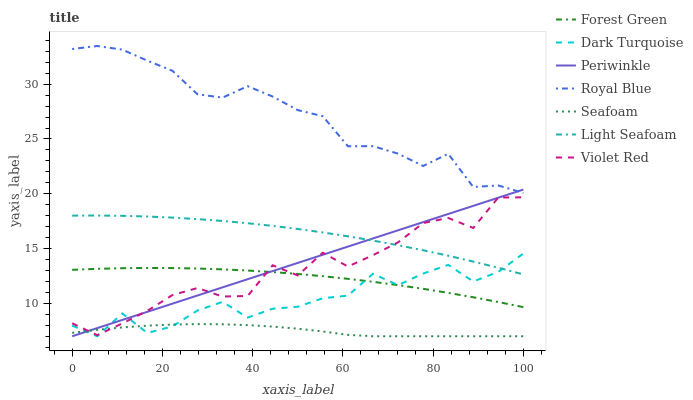Does Seafoam have the minimum area under the curve?
Answer yes or no. Yes. Does Royal Blue have the maximum area under the curve?
Answer yes or no. Yes. Does Dark Turquoise have the minimum area under the curve?
Answer yes or no. No. Does Dark Turquoise have the maximum area under the curve?
Answer yes or no. No. Is Periwinkle the smoothest?
Answer yes or no. Yes. Is Violet Red the roughest?
Answer yes or no. Yes. Is Dark Turquoise the smoothest?
Answer yes or no. No. Is Dark Turquoise the roughest?
Answer yes or no. No. Does Dark Turquoise have the lowest value?
Answer yes or no. Yes. Does Royal Blue have the lowest value?
Answer yes or no. No. Does Royal Blue have the highest value?
Answer yes or no. Yes. Does Dark Turquoise have the highest value?
Answer yes or no. No. Is Light Seafoam less than Royal Blue?
Answer yes or no. Yes. Is Royal Blue greater than Violet Red?
Answer yes or no. Yes. Does Violet Red intersect Dark Turquoise?
Answer yes or no. Yes. Is Violet Red less than Dark Turquoise?
Answer yes or no. No. Is Violet Red greater than Dark Turquoise?
Answer yes or no. No. Does Light Seafoam intersect Royal Blue?
Answer yes or no. No. 